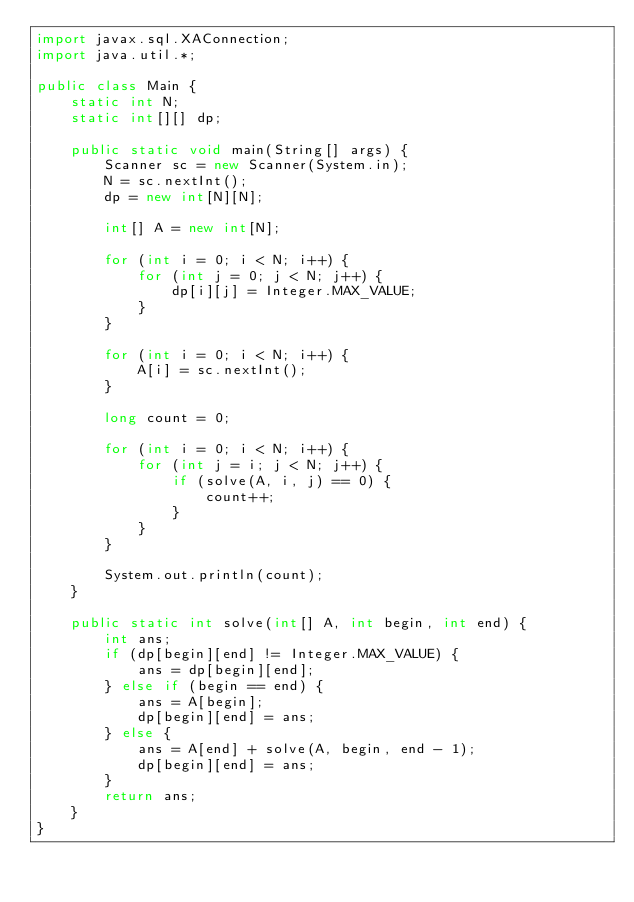Convert code to text. <code><loc_0><loc_0><loc_500><loc_500><_Java_>import javax.sql.XAConnection;
import java.util.*;

public class Main {
    static int N;
    static int[][] dp;

    public static void main(String[] args) {
        Scanner sc = new Scanner(System.in);
        N = sc.nextInt();
        dp = new int[N][N];

        int[] A = new int[N];

        for (int i = 0; i < N; i++) {
            for (int j = 0; j < N; j++) {
                dp[i][j] = Integer.MAX_VALUE;
            }
        }

        for (int i = 0; i < N; i++) {
            A[i] = sc.nextInt();
        }

        long count = 0;

        for (int i = 0; i < N; i++) {
            for (int j = i; j < N; j++) {
                if (solve(A, i, j) == 0) {
                    count++;
                }
            }
        }

        System.out.println(count);
    }

    public static int solve(int[] A, int begin, int end) {
        int ans;
        if (dp[begin][end] != Integer.MAX_VALUE) {
            ans = dp[begin][end];
        } else if (begin == end) {
            ans = A[begin];
            dp[begin][end] = ans;
        } else {
            ans = A[end] + solve(A, begin, end - 1);
            dp[begin][end] = ans;
        }
        return ans;
    }
}</code> 